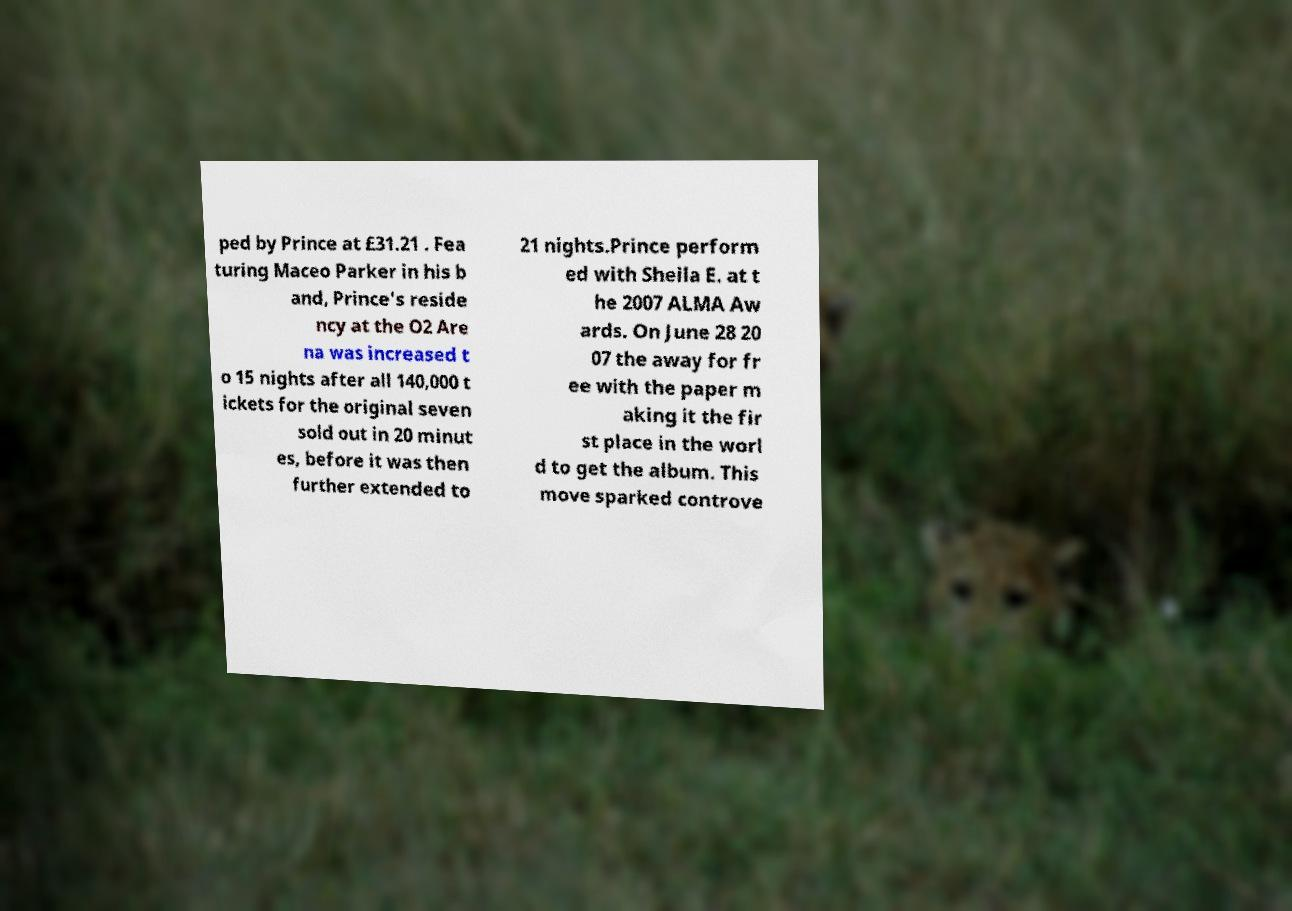Please identify and transcribe the text found in this image. ped by Prince at £31.21 . Fea turing Maceo Parker in his b and, Prince's reside ncy at the O2 Are na was increased t o 15 nights after all 140,000 t ickets for the original seven sold out in 20 minut es, before it was then further extended to 21 nights.Prince perform ed with Sheila E. at t he 2007 ALMA Aw ards. On June 28 20 07 the away for fr ee with the paper m aking it the fir st place in the worl d to get the album. This move sparked controve 